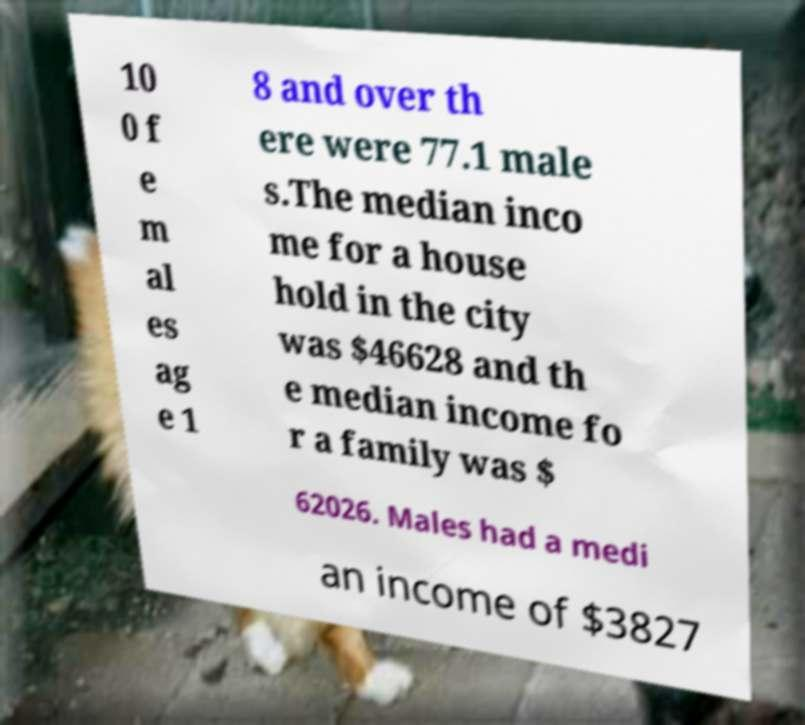I need the written content from this picture converted into text. Can you do that? 10 0 f e m al es ag e 1 8 and over th ere were 77.1 male s.The median inco me for a house hold in the city was $46628 and th e median income fo r a family was $ 62026. Males had a medi an income of $3827 